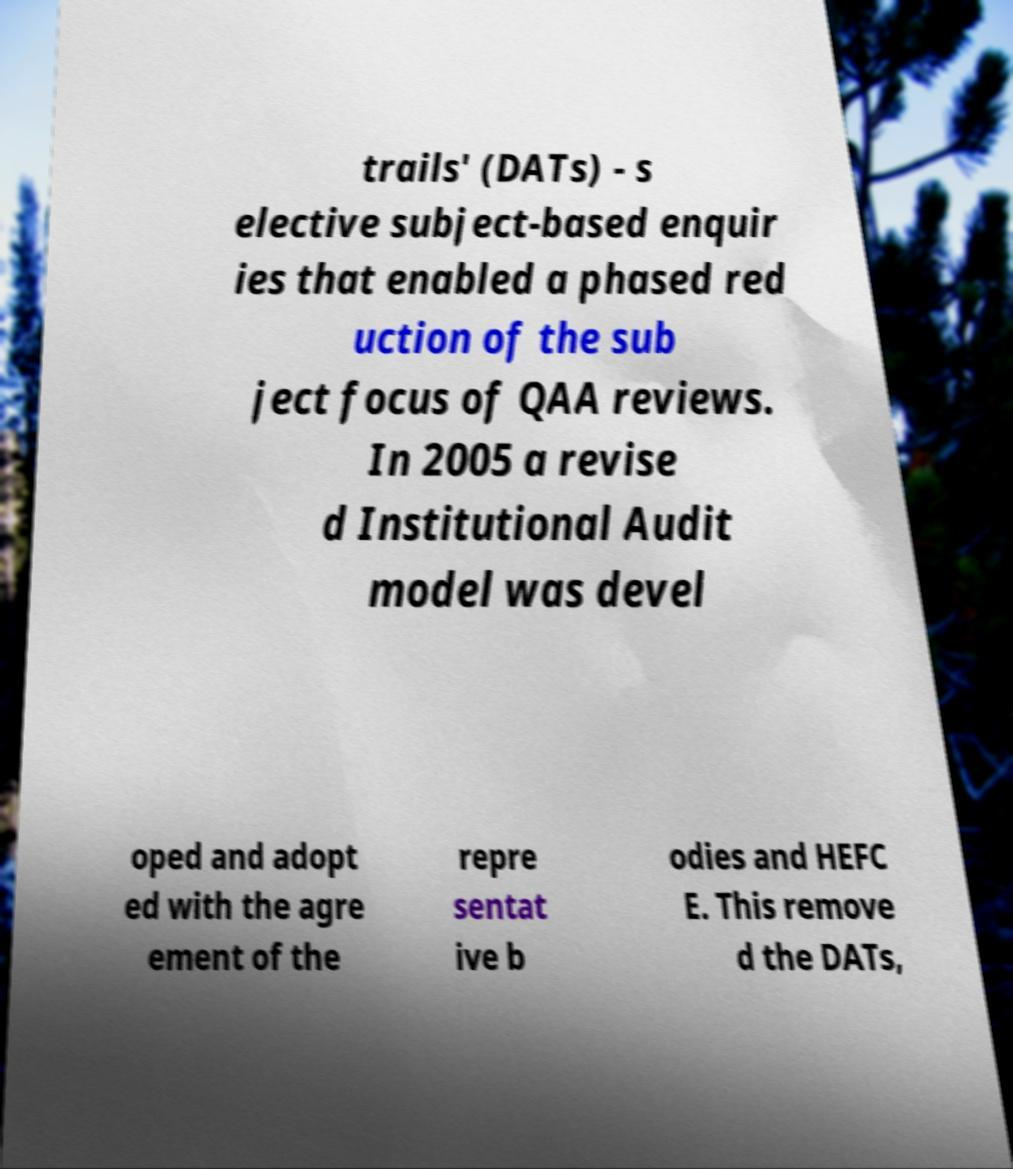For documentation purposes, I need the text within this image transcribed. Could you provide that? trails' (DATs) - s elective subject-based enquir ies that enabled a phased red uction of the sub ject focus of QAA reviews. In 2005 a revise d Institutional Audit model was devel oped and adopt ed with the agre ement of the repre sentat ive b odies and HEFC E. This remove d the DATs, 